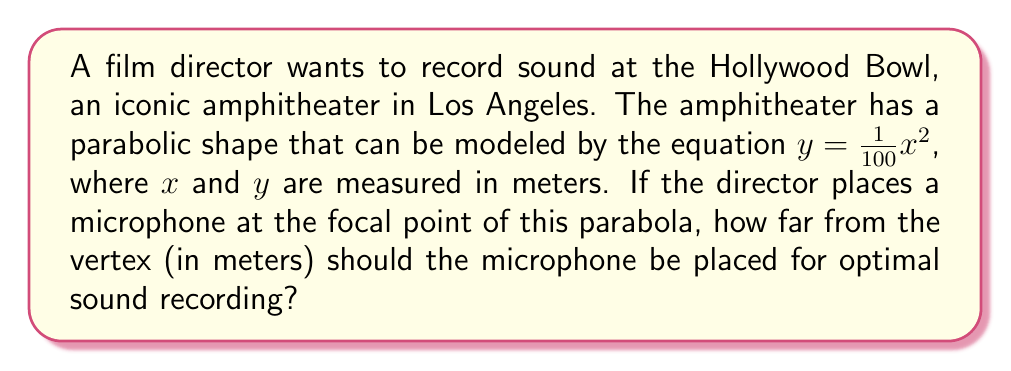Can you solve this math problem? To solve this problem, we need to follow these steps:

1) The general equation of a parabola with vertex at the origin is:
   $y = \frac{1}{4p}x^2$

2) Comparing this to our given equation $y = \frac{1}{100}x^2$, we can see that:
   $\frac{1}{4p} = \frac{1}{100}$

3) Solving for $p$:
   $p = \frac{100}{4} = 25$

4) In a parabola, the focal point is located at a distance of $p$ from the vertex along the axis of symmetry.

5) Therefore, the microphone should be placed 25 meters from the vertex of the parabola for optimal sound recording.

[asy]
import graph;
size(200,200);
real f(real x) {return x^2/100;}
draw(graph(f,-50,50));
dot((0,25),red);
label("Focal point (microphone)",(5,25),E);
label("Vertex",(0,0),SW);
draw((0,0)--(0,25),dashed);
label("25m",(0,12.5),W);
[/asy]
Answer: 25 meters 